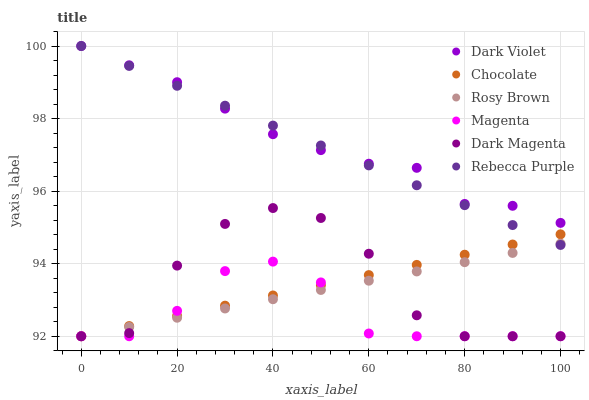Does Magenta have the minimum area under the curve?
Answer yes or no. Yes. Does Dark Violet have the maximum area under the curve?
Answer yes or no. Yes. Does Rosy Brown have the minimum area under the curve?
Answer yes or no. No. Does Rosy Brown have the maximum area under the curve?
Answer yes or no. No. Is Rosy Brown the smoothest?
Answer yes or no. Yes. Is Dark Magenta the roughest?
Answer yes or no. Yes. Is Dark Violet the smoothest?
Answer yes or no. No. Is Dark Violet the roughest?
Answer yes or no. No. Does Dark Magenta have the lowest value?
Answer yes or no. Yes. Does Dark Violet have the lowest value?
Answer yes or no. No. Does Rebecca Purple have the highest value?
Answer yes or no. Yes. Does Rosy Brown have the highest value?
Answer yes or no. No. Is Dark Magenta less than Rebecca Purple?
Answer yes or no. Yes. Is Dark Violet greater than Dark Magenta?
Answer yes or no. Yes. Does Chocolate intersect Magenta?
Answer yes or no. Yes. Is Chocolate less than Magenta?
Answer yes or no. No. Is Chocolate greater than Magenta?
Answer yes or no. No. Does Dark Magenta intersect Rebecca Purple?
Answer yes or no. No. 